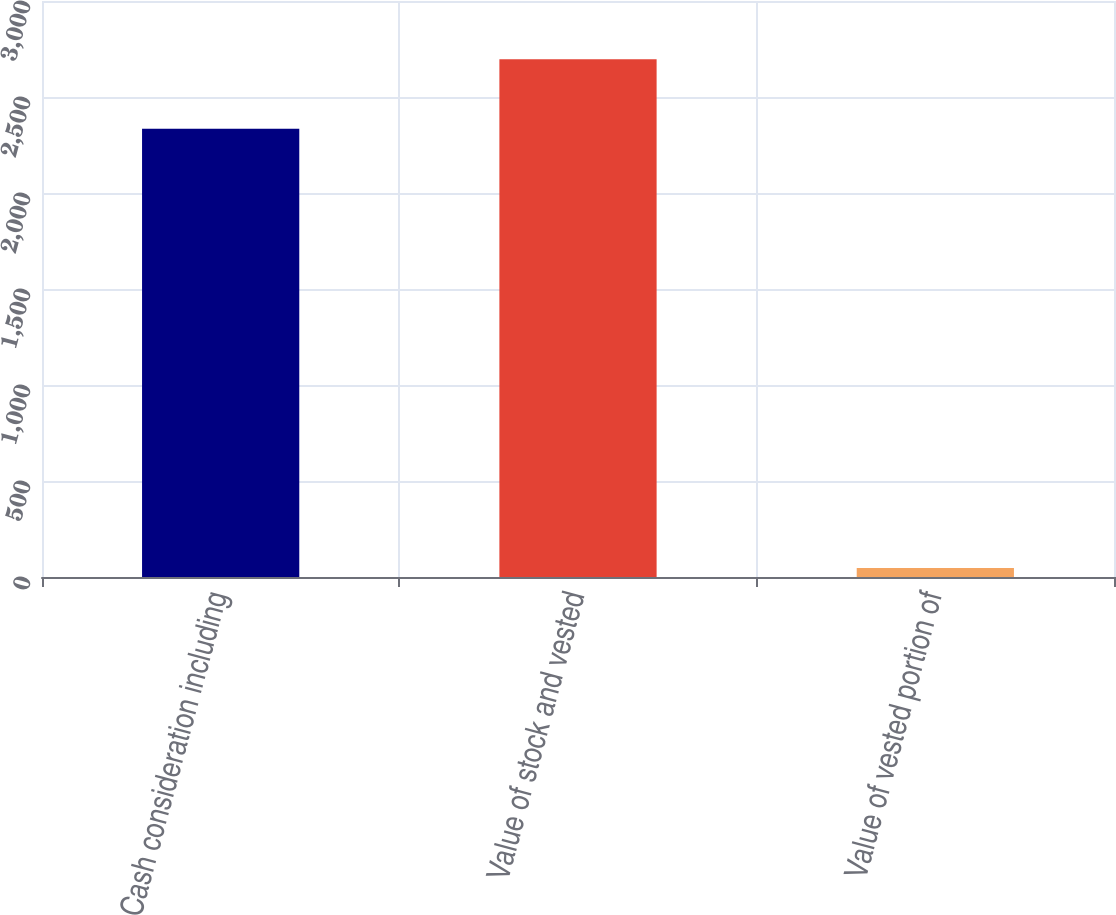Convert chart to OTSL. <chart><loc_0><loc_0><loc_500><loc_500><bar_chart><fcel>Cash consideration including<fcel>Value of stock and vested<fcel>Value of vested portion of<nl><fcel>2335<fcel>2697<fcel>47<nl></chart> 